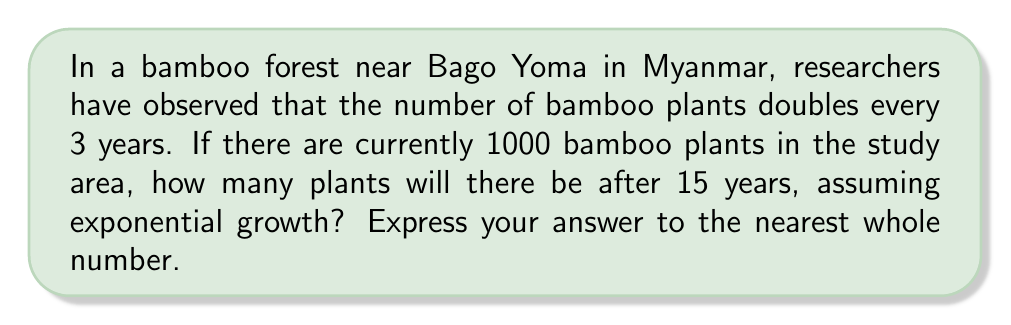Give your solution to this math problem. To solve this problem, we'll use the exponential growth model:

$$N(t) = N_0 \cdot e^{rt}$$

Where:
$N(t)$ is the number of bamboo plants at time $t$
$N_0$ is the initial number of bamboo plants
$e$ is Euler's number (approximately 2.71828)
$r$ is the growth rate
$t$ is the time in years

First, we need to calculate the growth rate $r$. We know that the population doubles every 3 years, so:

$$2 = e^{3r}$$

Taking the natural log of both sides:

$$\ln(2) = 3r$$

Solving for $r$:

$$r = \frac{\ln(2)}{3} \approx 0.2310$$

Now we can use the exponential growth formula with our known values:

$N_0 = 1000$ (initial number of plants)
$r \approx 0.2310$ (calculated growth rate)
$t = 15$ (time in years)

$$N(15) = 1000 \cdot e^{0.2310 \cdot 15}$$

Using a calculator or computer:

$$N(15) \approx 1000 \cdot 31.6228 \approx 31,622.78$$

Rounding to the nearest whole number, we get 31,623 bamboo plants after 15 years.
Answer: 31,623 bamboo plants 